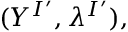Convert formula to latex. <formula><loc_0><loc_0><loc_500><loc_500>( Y ^ { I ^ { \prime } } , \lambda ^ { I ^ { \prime } } ) ,</formula> 